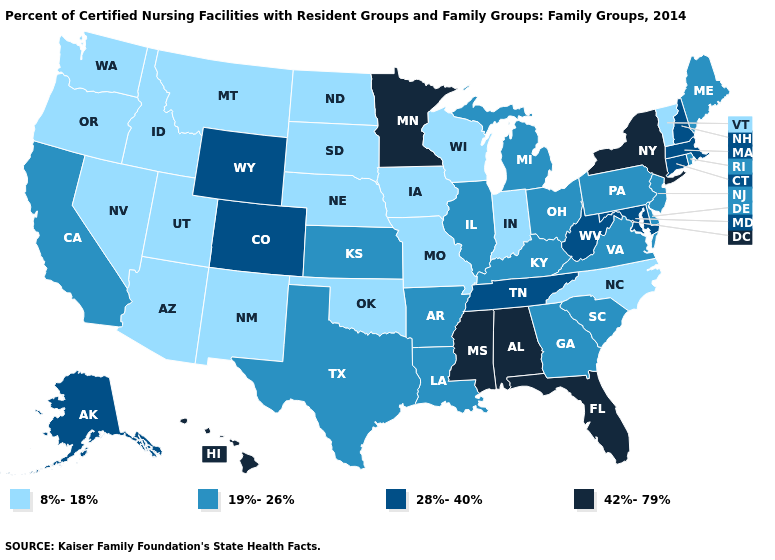What is the lowest value in the South?
Keep it brief. 8%-18%. Does Minnesota have the highest value in the MidWest?
Answer briefly. Yes. Which states have the lowest value in the USA?
Answer briefly. Arizona, Idaho, Indiana, Iowa, Missouri, Montana, Nebraska, Nevada, New Mexico, North Carolina, North Dakota, Oklahoma, Oregon, South Dakota, Utah, Vermont, Washington, Wisconsin. Name the states that have a value in the range 19%-26%?
Give a very brief answer. Arkansas, California, Delaware, Georgia, Illinois, Kansas, Kentucky, Louisiana, Maine, Michigan, New Jersey, Ohio, Pennsylvania, Rhode Island, South Carolina, Texas, Virginia. Which states hav the highest value in the Northeast?
Short answer required. New York. Name the states that have a value in the range 42%-79%?
Short answer required. Alabama, Florida, Hawaii, Minnesota, Mississippi, New York. Is the legend a continuous bar?
Answer briefly. No. Which states hav the highest value in the MidWest?
Quick response, please. Minnesota. Name the states that have a value in the range 8%-18%?
Answer briefly. Arizona, Idaho, Indiana, Iowa, Missouri, Montana, Nebraska, Nevada, New Mexico, North Carolina, North Dakota, Oklahoma, Oregon, South Dakota, Utah, Vermont, Washington, Wisconsin. What is the lowest value in states that border Utah?
Concise answer only. 8%-18%. Which states have the highest value in the USA?
Keep it brief. Alabama, Florida, Hawaii, Minnesota, Mississippi, New York. Name the states that have a value in the range 19%-26%?
Write a very short answer. Arkansas, California, Delaware, Georgia, Illinois, Kansas, Kentucky, Louisiana, Maine, Michigan, New Jersey, Ohio, Pennsylvania, Rhode Island, South Carolina, Texas, Virginia. Does New Mexico have a lower value than North Carolina?
Answer briefly. No. Name the states that have a value in the range 8%-18%?
Keep it brief. Arizona, Idaho, Indiana, Iowa, Missouri, Montana, Nebraska, Nevada, New Mexico, North Carolina, North Dakota, Oklahoma, Oregon, South Dakota, Utah, Vermont, Washington, Wisconsin. 